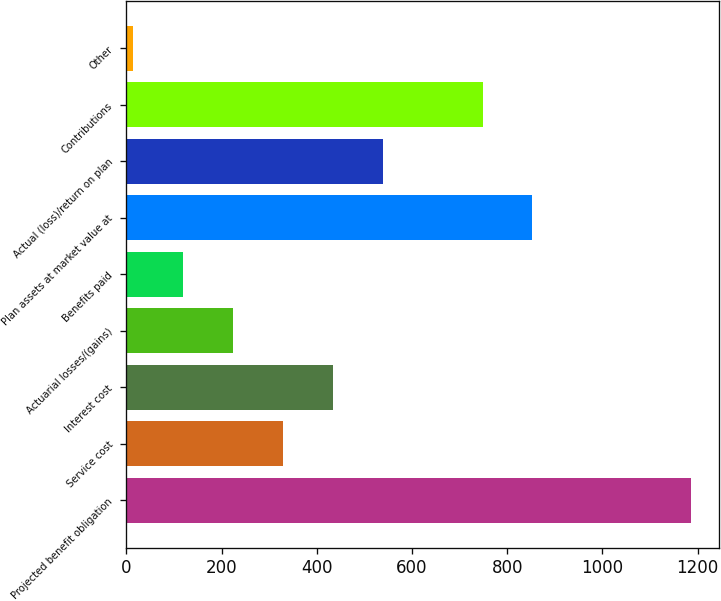<chart> <loc_0><loc_0><loc_500><loc_500><bar_chart><fcel>Projected benefit obligation<fcel>Service cost<fcel>Interest cost<fcel>Actuarial losses/(gains)<fcel>Benefits paid<fcel>Plan assets at market value at<fcel>Actual (loss)/return on plan<fcel>Contributions<fcel>Other<nl><fcel>1186.8<fcel>328.7<fcel>433.6<fcel>223.8<fcel>118.9<fcel>853.2<fcel>538.5<fcel>748.3<fcel>14<nl></chart> 